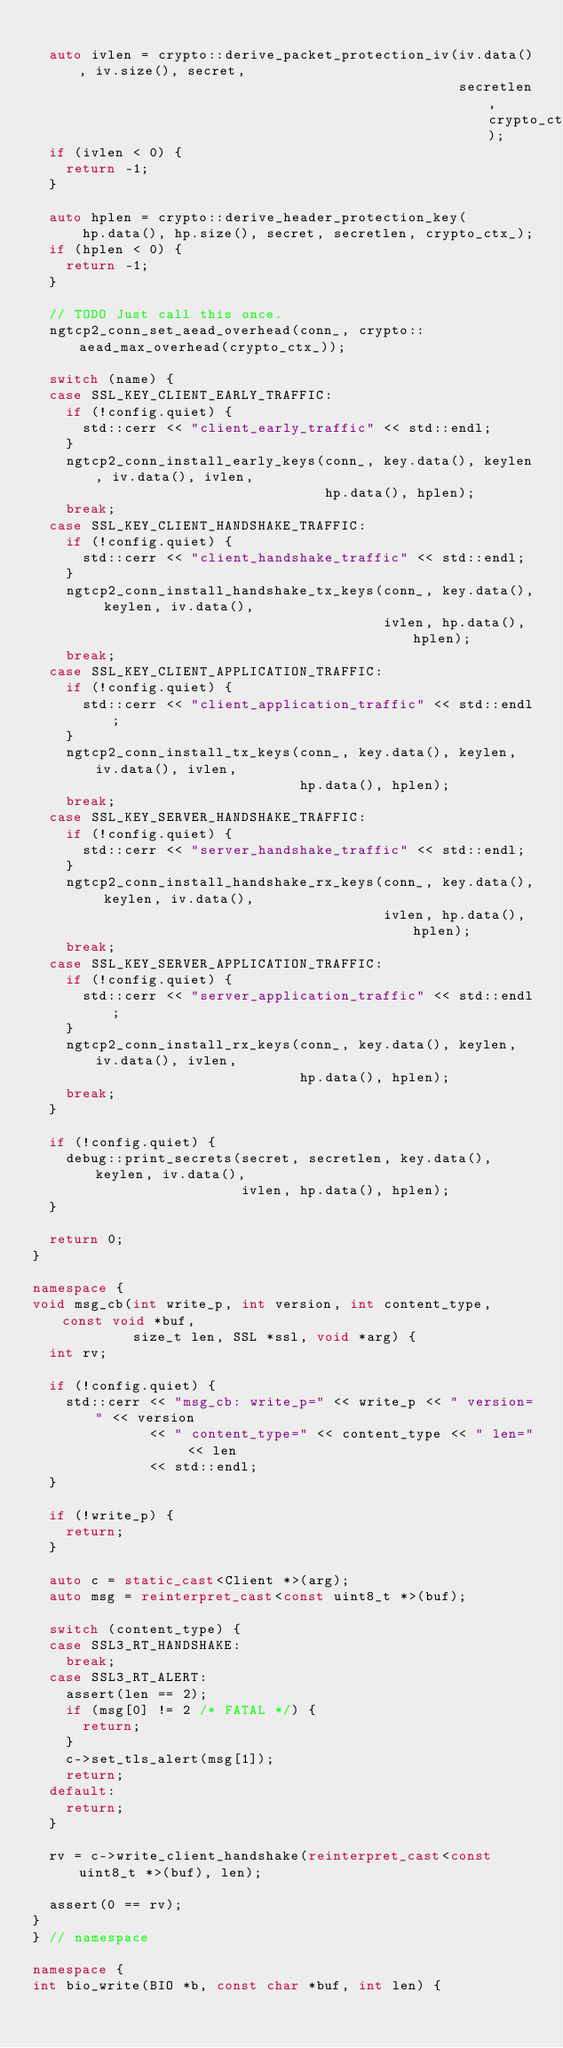<code> <loc_0><loc_0><loc_500><loc_500><_C++_>
  auto ivlen = crypto::derive_packet_protection_iv(iv.data(), iv.size(), secret,
                                                   secretlen, crypto_ctx_);
  if (ivlen < 0) {
    return -1;
  }

  auto hplen = crypto::derive_header_protection_key(
      hp.data(), hp.size(), secret, secretlen, crypto_ctx_);
  if (hplen < 0) {
    return -1;
  }

  // TODO Just call this once.
  ngtcp2_conn_set_aead_overhead(conn_, crypto::aead_max_overhead(crypto_ctx_));

  switch (name) {
  case SSL_KEY_CLIENT_EARLY_TRAFFIC:
    if (!config.quiet) {
      std::cerr << "client_early_traffic" << std::endl;
    }
    ngtcp2_conn_install_early_keys(conn_, key.data(), keylen, iv.data(), ivlen,
                                   hp.data(), hplen);
    break;
  case SSL_KEY_CLIENT_HANDSHAKE_TRAFFIC:
    if (!config.quiet) {
      std::cerr << "client_handshake_traffic" << std::endl;
    }
    ngtcp2_conn_install_handshake_tx_keys(conn_, key.data(), keylen, iv.data(),
                                          ivlen, hp.data(), hplen);
    break;
  case SSL_KEY_CLIENT_APPLICATION_TRAFFIC:
    if (!config.quiet) {
      std::cerr << "client_application_traffic" << std::endl;
    }
    ngtcp2_conn_install_tx_keys(conn_, key.data(), keylen, iv.data(), ivlen,
                                hp.data(), hplen);
    break;
  case SSL_KEY_SERVER_HANDSHAKE_TRAFFIC:
    if (!config.quiet) {
      std::cerr << "server_handshake_traffic" << std::endl;
    }
    ngtcp2_conn_install_handshake_rx_keys(conn_, key.data(), keylen, iv.data(),
                                          ivlen, hp.data(), hplen);
    break;
  case SSL_KEY_SERVER_APPLICATION_TRAFFIC:
    if (!config.quiet) {
      std::cerr << "server_application_traffic" << std::endl;
    }
    ngtcp2_conn_install_rx_keys(conn_, key.data(), keylen, iv.data(), ivlen,
                                hp.data(), hplen);
    break;
  }

  if (!config.quiet) {
    debug::print_secrets(secret, secretlen, key.data(), keylen, iv.data(),
                         ivlen, hp.data(), hplen);
  }

  return 0;
}

namespace {
void msg_cb(int write_p, int version, int content_type, const void *buf,
            size_t len, SSL *ssl, void *arg) {
  int rv;

  if (!config.quiet) {
    std::cerr << "msg_cb: write_p=" << write_p << " version=" << version
              << " content_type=" << content_type << " len=" << len
              << std::endl;
  }

  if (!write_p) {
    return;
  }

  auto c = static_cast<Client *>(arg);
  auto msg = reinterpret_cast<const uint8_t *>(buf);

  switch (content_type) {
  case SSL3_RT_HANDSHAKE:
    break;
  case SSL3_RT_ALERT:
    assert(len == 2);
    if (msg[0] != 2 /* FATAL */) {
      return;
    }
    c->set_tls_alert(msg[1]);
    return;
  default:
    return;
  }

  rv = c->write_client_handshake(reinterpret_cast<const uint8_t *>(buf), len);

  assert(0 == rv);
}
} // namespace

namespace {
int bio_write(BIO *b, const char *buf, int len) {</code> 